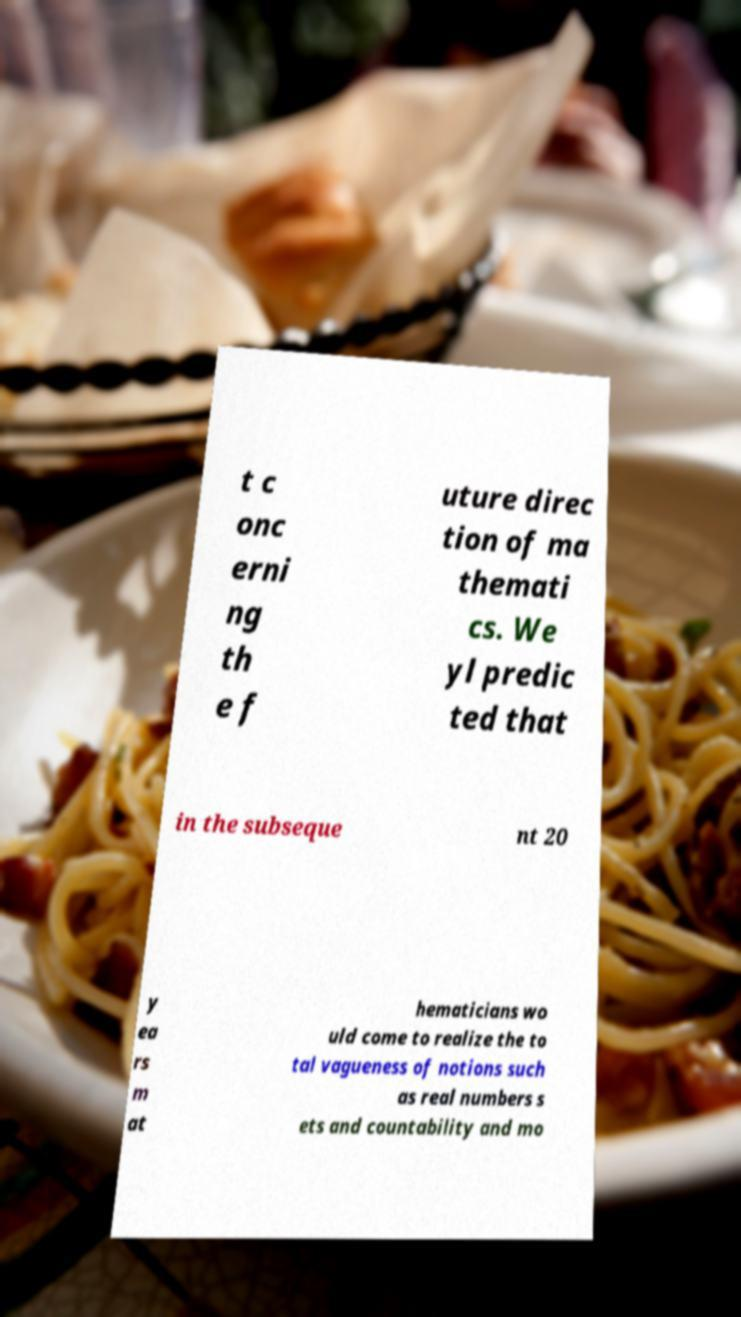What messages or text are displayed in this image? I need them in a readable, typed format. t c onc erni ng th e f uture direc tion of ma themati cs. We yl predic ted that in the subseque nt 20 y ea rs m at hematicians wo uld come to realize the to tal vagueness of notions such as real numbers s ets and countability and mo 